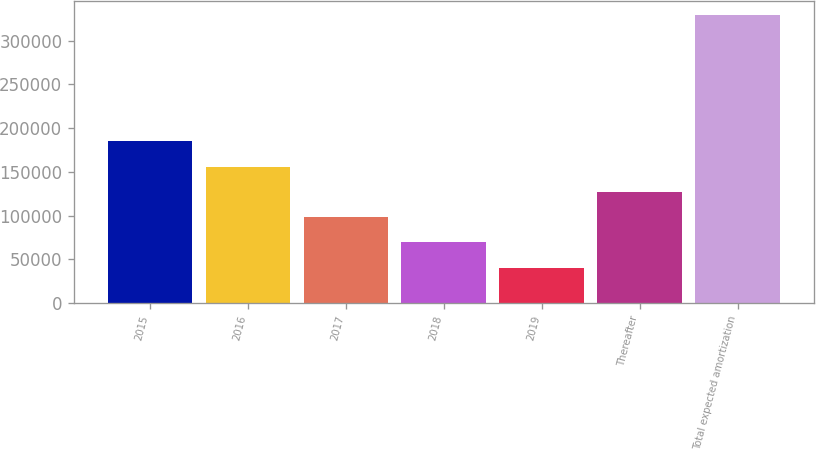Convert chart. <chart><loc_0><loc_0><loc_500><loc_500><bar_chart><fcel>2015<fcel>2016<fcel>2017<fcel>2018<fcel>2019<fcel>Thereafter<fcel>Total expected amortization<nl><fcel>184880<fcel>156026<fcel>98318.2<fcel>69464.1<fcel>40610<fcel>127172<fcel>329151<nl></chart> 